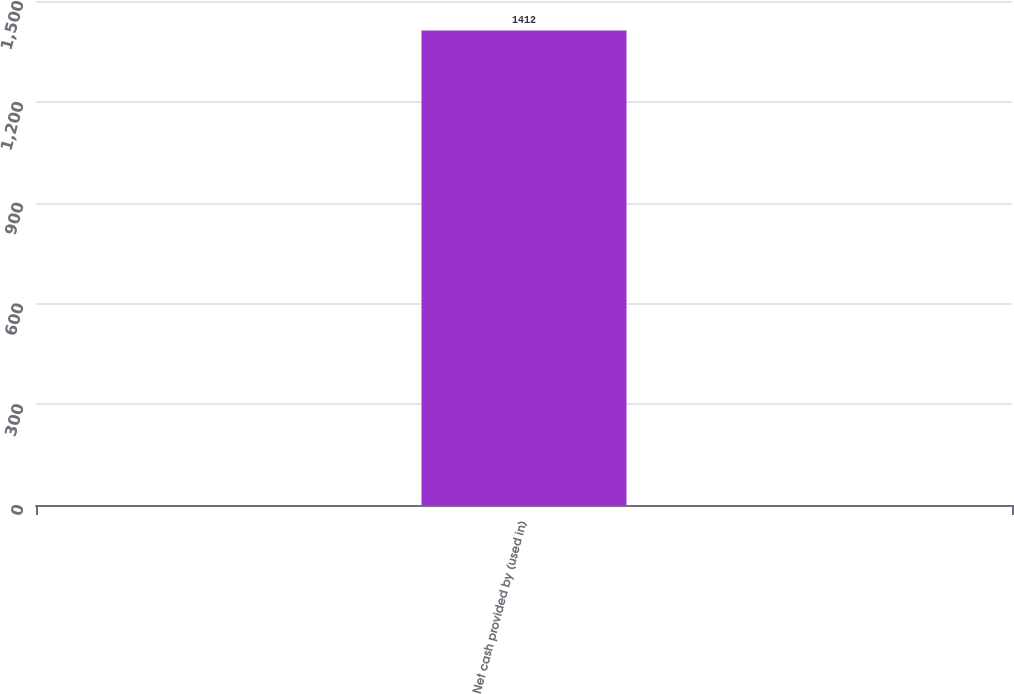<chart> <loc_0><loc_0><loc_500><loc_500><bar_chart><fcel>Net cash provided by (used in)<nl><fcel>1412<nl></chart> 